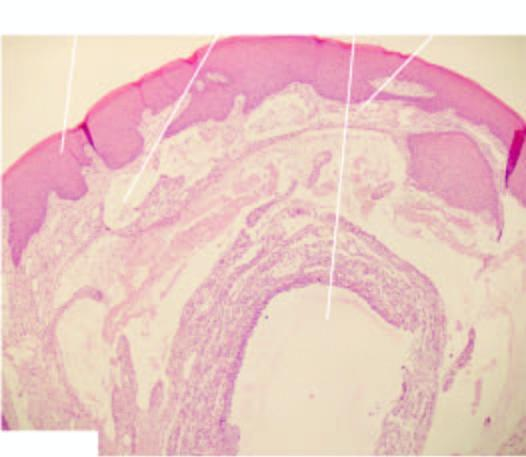s there inflammatory reaction around extravasated mucus?
Answer the question using a single word or phrase. Yes 